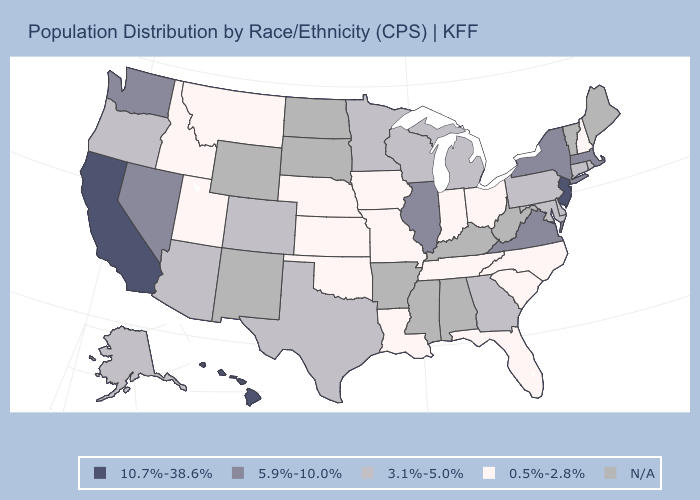What is the highest value in the USA?
Give a very brief answer. 10.7%-38.6%. What is the value of Nevada?
Write a very short answer. 5.9%-10.0%. Which states have the lowest value in the USA?
Be succinct. Florida, Idaho, Indiana, Iowa, Kansas, Louisiana, Missouri, Montana, Nebraska, New Hampshire, North Carolina, Ohio, Oklahoma, South Carolina, Tennessee, Utah. What is the lowest value in the MidWest?
Answer briefly. 0.5%-2.8%. What is the value of Missouri?
Keep it brief. 0.5%-2.8%. How many symbols are there in the legend?
Keep it brief. 5. What is the value of Nebraska?
Give a very brief answer. 0.5%-2.8%. Name the states that have a value in the range 0.5%-2.8%?
Be succinct. Florida, Idaho, Indiana, Iowa, Kansas, Louisiana, Missouri, Montana, Nebraska, New Hampshire, North Carolina, Ohio, Oklahoma, South Carolina, Tennessee, Utah. Name the states that have a value in the range 3.1%-5.0%?
Be succinct. Alaska, Arizona, Colorado, Connecticut, Delaware, Georgia, Maryland, Michigan, Minnesota, Oregon, Pennsylvania, Rhode Island, Texas, Wisconsin. What is the value of North Dakota?
Quick response, please. N/A. Among the states that border Kentucky , which have the highest value?
Answer briefly. Illinois, Virginia. Name the states that have a value in the range 5.9%-10.0%?
Quick response, please. Illinois, Massachusetts, Nevada, New York, Virginia, Washington. What is the value of Arkansas?
Short answer required. N/A. 